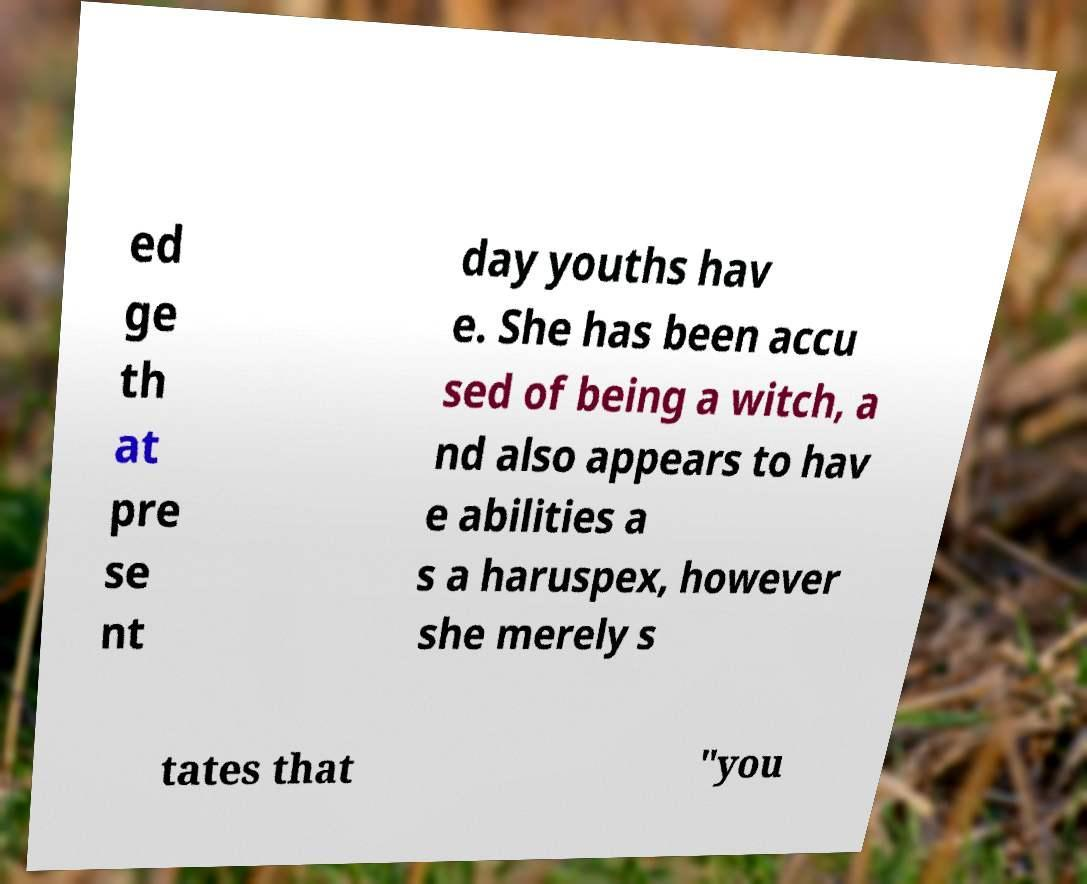Could you extract and type out the text from this image? ed ge th at pre se nt day youths hav e. She has been accu sed of being a witch, a nd also appears to hav e abilities a s a haruspex, however she merely s tates that "you 